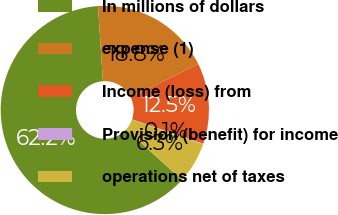Convert chart to OTSL. <chart><loc_0><loc_0><loc_500><loc_500><pie_chart><fcel>In millions of dollars<fcel>expense (1)<fcel>Income (loss) from<fcel>Provision (benefit) for income<fcel>operations net of taxes<nl><fcel>62.24%<fcel>18.76%<fcel>12.55%<fcel>0.12%<fcel>6.34%<nl></chart> 